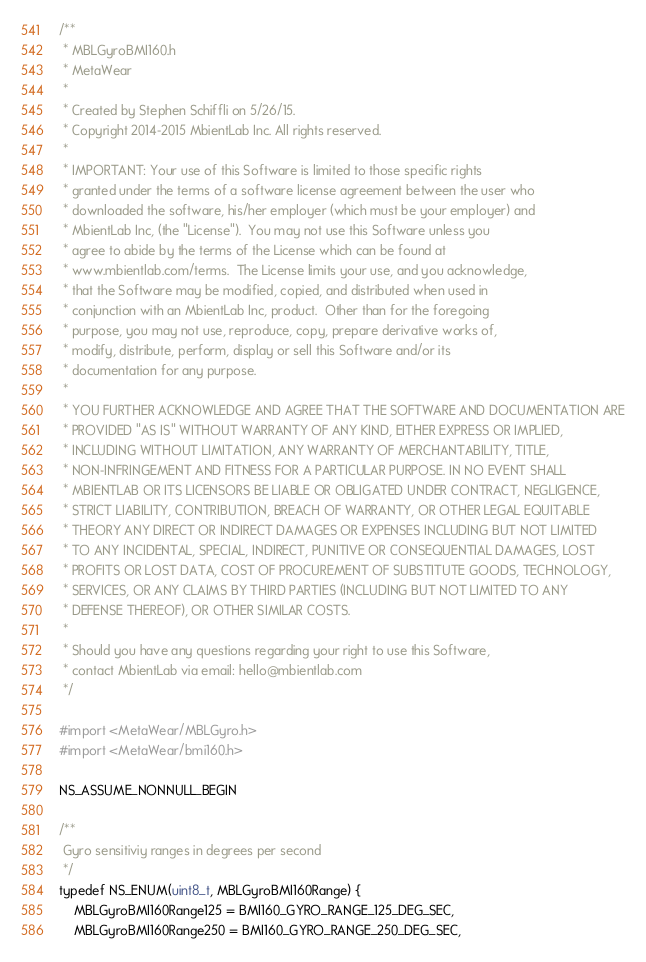<code> <loc_0><loc_0><loc_500><loc_500><_C_>/**
 * MBLGyroBMI160.h
 * MetaWear
 *
 * Created by Stephen Schiffli on 5/26/15.
 * Copyright 2014-2015 MbientLab Inc. All rights reserved.
 *
 * IMPORTANT: Your use of this Software is limited to those specific rights
 * granted under the terms of a software license agreement between the user who
 * downloaded the software, his/her employer (which must be your employer) and
 * MbientLab Inc, (the "License").  You may not use this Software unless you
 * agree to abide by the terms of the License which can be found at
 * www.mbientlab.com/terms.  The License limits your use, and you acknowledge,
 * that the Software may be modified, copied, and distributed when used in
 * conjunction with an MbientLab Inc, product.  Other than for the foregoing
 * purpose, you may not use, reproduce, copy, prepare derivative works of,
 * modify, distribute, perform, display or sell this Software and/or its
 * documentation for any purpose.
 *
 * YOU FURTHER ACKNOWLEDGE AND AGREE THAT THE SOFTWARE AND DOCUMENTATION ARE
 * PROVIDED "AS IS" WITHOUT WARRANTY OF ANY KIND, EITHER EXPRESS OR IMPLIED,
 * INCLUDING WITHOUT LIMITATION, ANY WARRANTY OF MERCHANTABILITY, TITLE,
 * NON-INFRINGEMENT AND FITNESS FOR A PARTICULAR PURPOSE. IN NO EVENT SHALL
 * MBIENTLAB OR ITS LICENSORS BE LIABLE OR OBLIGATED UNDER CONTRACT, NEGLIGENCE,
 * STRICT LIABILITY, CONTRIBUTION, BREACH OF WARRANTY, OR OTHER LEGAL EQUITABLE
 * THEORY ANY DIRECT OR INDIRECT DAMAGES OR EXPENSES INCLUDING BUT NOT LIMITED
 * TO ANY INCIDENTAL, SPECIAL, INDIRECT, PUNITIVE OR CONSEQUENTIAL DAMAGES, LOST
 * PROFITS OR LOST DATA, COST OF PROCUREMENT OF SUBSTITUTE GOODS, TECHNOLOGY,
 * SERVICES, OR ANY CLAIMS BY THIRD PARTIES (INCLUDING BUT NOT LIMITED TO ANY
 * DEFENSE THEREOF), OR OTHER SIMILAR COSTS.
 *
 * Should you have any questions regarding your right to use this Software,
 * contact MbientLab via email: hello@mbientlab.com
 */

#import <MetaWear/MBLGyro.h>
#import <MetaWear/bmi160.h>

NS_ASSUME_NONNULL_BEGIN

/**
 Gyro sensitiviy ranges in degrees per second
 */
typedef NS_ENUM(uint8_t, MBLGyroBMI160Range) {
    MBLGyroBMI160Range125 = BMI160_GYRO_RANGE_125_DEG_SEC,
    MBLGyroBMI160Range250 = BMI160_GYRO_RANGE_250_DEG_SEC,</code> 